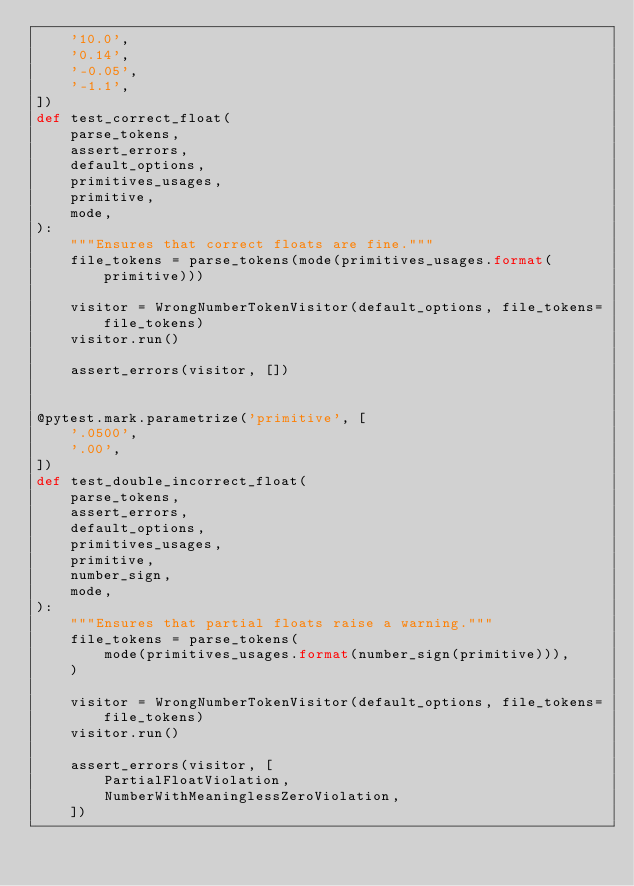Convert code to text. <code><loc_0><loc_0><loc_500><loc_500><_Python_>    '10.0',
    '0.14',
    '-0.05',
    '-1.1',
])
def test_correct_float(
    parse_tokens,
    assert_errors,
    default_options,
    primitives_usages,
    primitive,
    mode,
):
    """Ensures that correct floats are fine."""
    file_tokens = parse_tokens(mode(primitives_usages.format(primitive)))

    visitor = WrongNumberTokenVisitor(default_options, file_tokens=file_tokens)
    visitor.run()

    assert_errors(visitor, [])


@pytest.mark.parametrize('primitive', [
    '.0500',
    '.00',
])
def test_double_incorrect_float(
    parse_tokens,
    assert_errors,
    default_options,
    primitives_usages,
    primitive,
    number_sign,
    mode,
):
    """Ensures that partial floats raise a warning."""
    file_tokens = parse_tokens(
        mode(primitives_usages.format(number_sign(primitive))),
    )

    visitor = WrongNumberTokenVisitor(default_options, file_tokens=file_tokens)
    visitor.run()

    assert_errors(visitor, [
        PartialFloatViolation,
        NumberWithMeaninglessZeroViolation,
    ])
</code> 